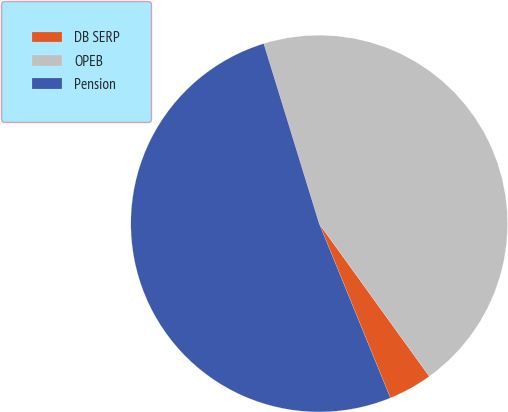<chart> <loc_0><loc_0><loc_500><loc_500><pie_chart><fcel>DB SERP<fcel>OPEB<fcel>Pension<nl><fcel>3.77%<fcel>44.81%<fcel>51.42%<nl></chart> 